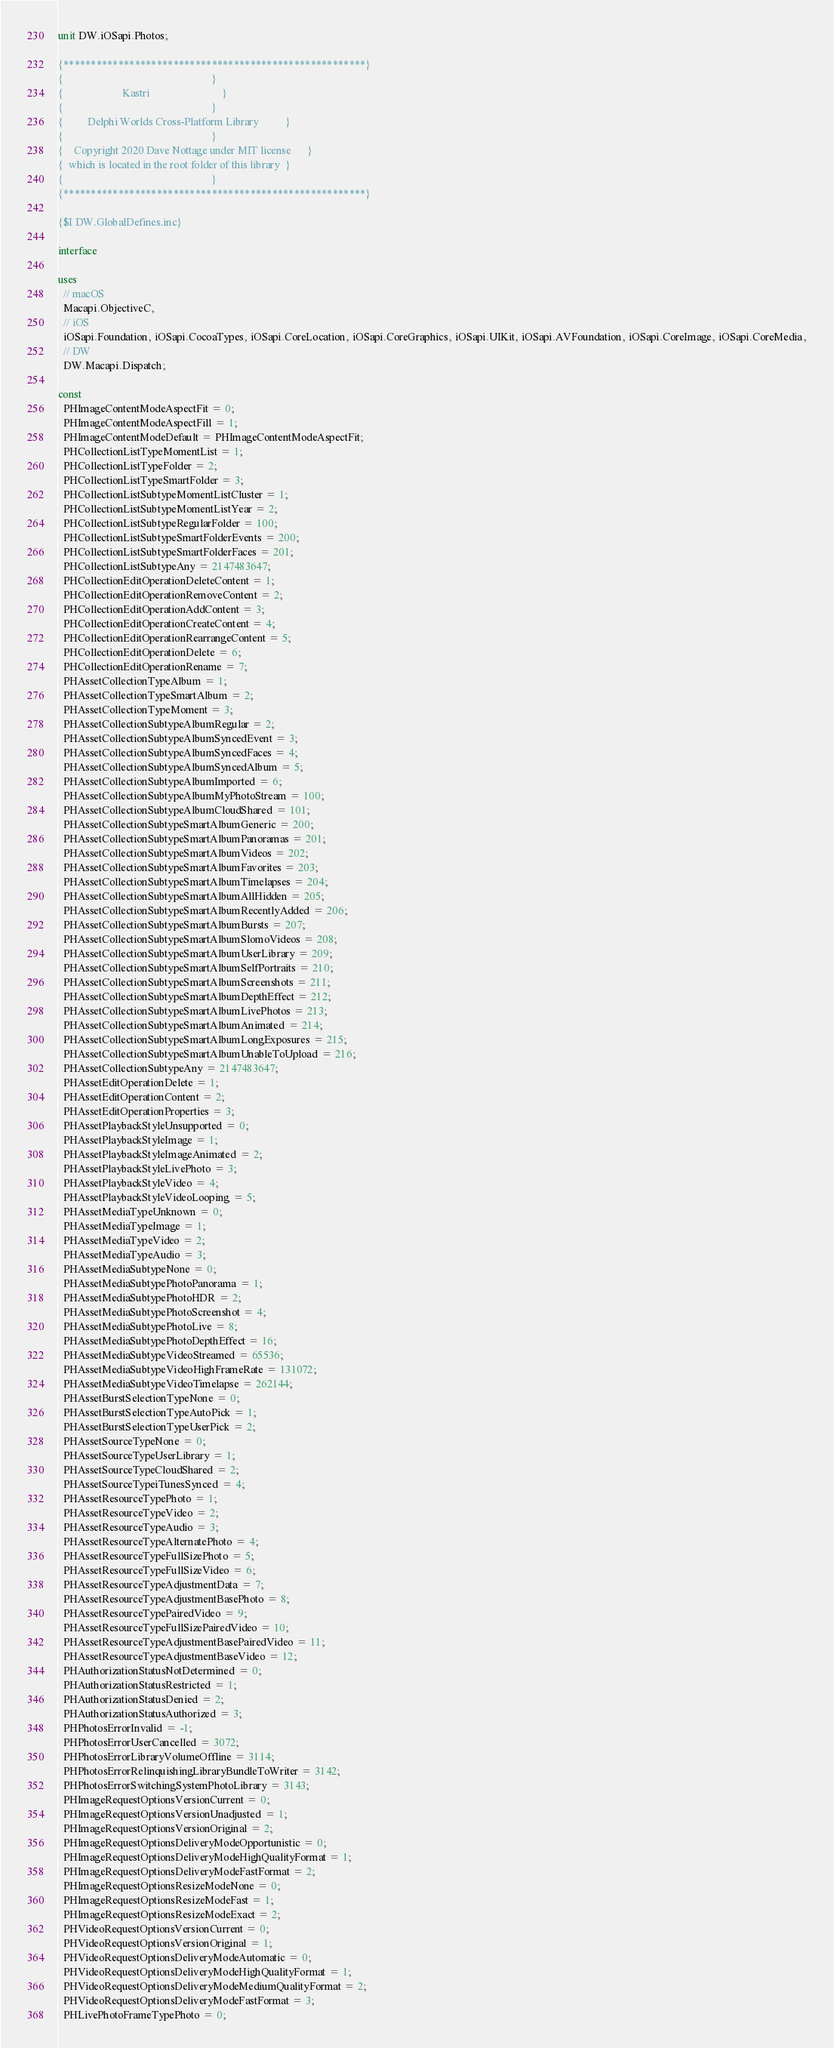Convert code to text. <code><loc_0><loc_0><loc_500><loc_500><_Pascal_>unit DW.iOSapi.Photos;

{*******************************************************}
{                                                       }
{                      Kastri                           }
{                                                       }
{         Delphi Worlds Cross-Platform Library          }
{                                                       }
{    Copyright 2020 Dave Nottage under MIT license      }
{  which is located in the root folder of this library  }
{                                                       }
{*******************************************************}

{$I DW.GlobalDefines.inc}

interface

uses
  // macOS
  Macapi.ObjectiveC,
  // iOS
  iOSapi.Foundation, iOSapi.CocoaTypes, iOSapi.CoreLocation, iOSapi.CoreGraphics, iOSapi.UIKit, iOSapi.AVFoundation, iOSapi.CoreImage, iOSapi.CoreMedia,
  // DW
  DW.Macapi.Dispatch;

const
  PHImageContentModeAspectFit = 0;
  PHImageContentModeAspectFill = 1;
  PHImageContentModeDefault = PHImageContentModeAspectFit;
  PHCollectionListTypeMomentList = 1;
  PHCollectionListTypeFolder = 2;
  PHCollectionListTypeSmartFolder = 3;
  PHCollectionListSubtypeMomentListCluster = 1;
  PHCollectionListSubtypeMomentListYear = 2;
  PHCollectionListSubtypeRegularFolder = 100;
  PHCollectionListSubtypeSmartFolderEvents = 200;
  PHCollectionListSubtypeSmartFolderFaces = 201;
  PHCollectionListSubtypeAny = 2147483647;
  PHCollectionEditOperationDeleteContent = 1;
  PHCollectionEditOperationRemoveContent = 2;
  PHCollectionEditOperationAddContent = 3;
  PHCollectionEditOperationCreateContent = 4;
  PHCollectionEditOperationRearrangeContent = 5;
  PHCollectionEditOperationDelete = 6;
  PHCollectionEditOperationRename = 7;
  PHAssetCollectionTypeAlbum = 1;
  PHAssetCollectionTypeSmartAlbum = 2;
  PHAssetCollectionTypeMoment = 3;
  PHAssetCollectionSubtypeAlbumRegular = 2;
  PHAssetCollectionSubtypeAlbumSyncedEvent = 3;
  PHAssetCollectionSubtypeAlbumSyncedFaces = 4;
  PHAssetCollectionSubtypeAlbumSyncedAlbum = 5;
  PHAssetCollectionSubtypeAlbumImported = 6;
  PHAssetCollectionSubtypeAlbumMyPhotoStream = 100;
  PHAssetCollectionSubtypeAlbumCloudShared = 101;
  PHAssetCollectionSubtypeSmartAlbumGeneric = 200;
  PHAssetCollectionSubtypeSmartAlbumPanoramas = 201;
  PHAssetCollectionSubtypeSmartAlbumVideos = 202;
  PHAssetCollectionSubtypeSmartAlbumFavorites = 203;
  PHAssetCollectionSubtypeSmartAlbumTimelapses = 204;
  PHAssetCollectionSubtypeSmartAlbumAllHidden = 205;
  PHAssetCollectionSubtypeSmartAlbumRecentlyAdded = 206;
  PHAssetCollectionSubtypeSmartAlbumBursts = 207;
  PHAssetCollectionSubtypeSmartAlbumSlomoVideos = 208;
  PHAssetCollectionSubtypeSmartAlbumUserLibrary = 209;
  PHAssetCollectionSubtypeSmartAlbumSelfPortraits = 210;
  PHAssetCollectionSubtypeSmartAlbumScreenshots = 211;
  PHAssetCollectionSubtypeSmartAlbumDepthEffect = 212;
  PHAssetCollectionSubtypeSmartAlbumLivePhotos = 213;
  PHAssetCollectionSubtypeSmartAlbumAnimated = 214;
  PHAssetCollectionSubtypeSmartAlbumLongExposures = 215;
  PHAssetCollectionSubtypeSmartAlbumUnableToUpload = 216;
  PHAssetCollectionSubtypeAny = 2147483647;
  PHAssetEditOperationDelete = 1;
  PHAssetEditOperationContent = 2;
  PHAssetEditOperationProperties = 3;
  PHAssetPlaybackStyleUnsupported = 0;
  PHAssetPlaybackStyleImage = 1;
  PHAssetPlaybackStyleImageAnimated = 2;
  PHAssetPlaybackStyleLivePhoto = 3;
  PHAssetPlaybackStyleVideo = 4;
  PHAssetPlaybackStyleVideoLooping = 5;
  PHAssetMediaTypeUnknown = 0;
  PHAssetMediaTypeImage = 1;
  PHAssetMediaTypeVideo = 2;
  PHAssetMediaTypeAudio = 3;
  PHAssetMediaSubtypeNone = 0;
  PHAssetMediaSubtypePhotoPanorama = 1;
  PHAssetMediaSubtypePhotoHDR = 2;
  PHAssetMediaSubtypePhotoScreenshot = 4;
  PHAssetMediaSubtypePhotoLive = 8;
  PHAssetMediaSubtypePhotoDepthEffect = 16;
  PHAssetMediaSubtypeVideoStreamed = 65536;
  PHAssetMediaSubtypeVideoHighFrameRate = 131072;
  PHAssetMediaSubtypeVideoTimelapse = 262144;
  PHAssetBurstSelectionTypeNone = 0;
  PHAssetBurstSelectionTypeAutoPick = 1;
  PHAssetBurstSelectionTypeUserPick = 2;
  PHAssetSourceTypeNone = 0;
  PHAssetSourceTypeUserLibrary = 1;
  PHAssetSourceTypeCloudShared = 2;
  PHAssetSourceTypeiTunesSynced = 4;
  PHAssetResourceTypePhoto = 1;
  PHAssetResourceTypeVideo = 2;
  PHAssetResourceTypeAudio = 3;
  PHAssetResourceTypeAlternatePhoto = 4;
  PHAssetResourceTypeFullSizePhoto = 5;
  PHAssetResourceTypeFullSizeVideo = 6;
  PHAssetResourceTypeAdjustmentData = 7;
  PHAssetResourceTypeAdjustmentBasePhoto = 8;
  PHAssetResourceTypePairedVideo = 9;
  PHAssetResourceTypeFullSizePairedVideo = 10;
  PHAssetResourceTypeAdjustmentBasePairedVideo = 11;
  PHAssetResourceTypeAdjustmentBaseVideo = 12;
  PHAuthorizationStatusNotDetermined = 0;
  PHAuthorizationStatusRestricted = 1;
  PHAuthorizationStatusDenied = 2;
  PHAuthorizationStatusAuthorized = 3;
  PHPhotosErrorInvalid = -1;
  PHPhotosErrorUserCancelled = 3072;
  PHPhotosErrorLibraryVolumeOffline = 3114;
  PHPhotosErrorRelinquishingLibraryBundleToWriter = 3142;
  PHPhotosErrorSwitchingSystemPhotoLibrary = 3143;
  PHImageRequestOptionsVersionCurrent = 0;
  PHImageRequestOptionsVersionUnadjusted = 1;
  PHImageRequestOptionsVersionOriginal = 2;
  PHImageRequestOptionsDeliveryModeOpportunistic = 0;
  PHImageRequestOptionsDeliveryModeHighQualityFormat = 1;
  PHImageRequestOptionsDeliveryModeFastFormat = 2;
  PHImageRequestOptionsResizeModeNone = 0;
  PHImageRequestOptionsResizeModeFast = 1;
  PHImageRequestOptionsResizeModeExact = 2;
  PHVideoRequestOptionsVersionCurrent = 0;
  PHVideoRequestOptionsVersionOriginal = 1;
  PHVideoRequestOptionsDeliveryModeAutomatic = 0;
  PHVideoRequestOptionsDeliveryModeHighQualityFormat = 1;
  PHVideoRequestOptionsDeliveryModeMediumQualityFormat = 2;
  PHVideoRequestOptionsDeliveryModeFastFormat = 3;
  PHLivePhotoFrameTypePhoto = 0;</code> 